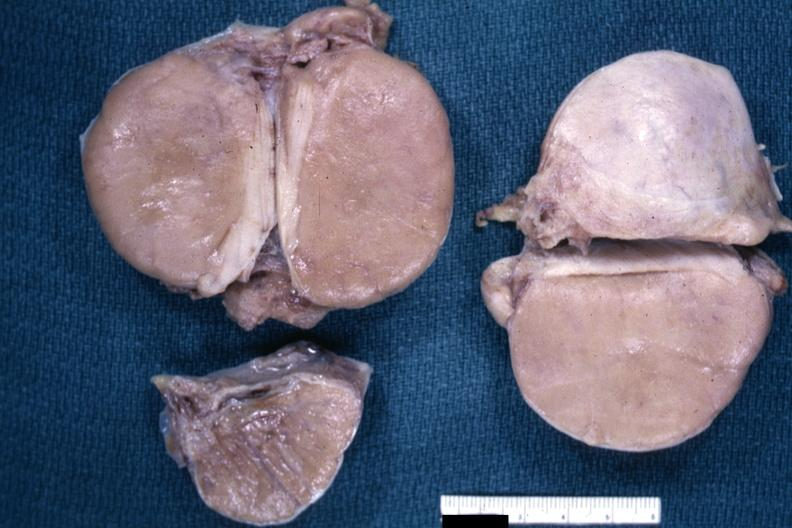what is present?
Answer the question using a single word or phrase. Testicle 